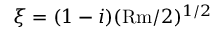Convert formula to latex. <formula><loc_0><loc_0><loc_500><loc_500>\xi = ( 1 - i ) ( R m / 2 ) ^ { 1 / 2 }</formula> 